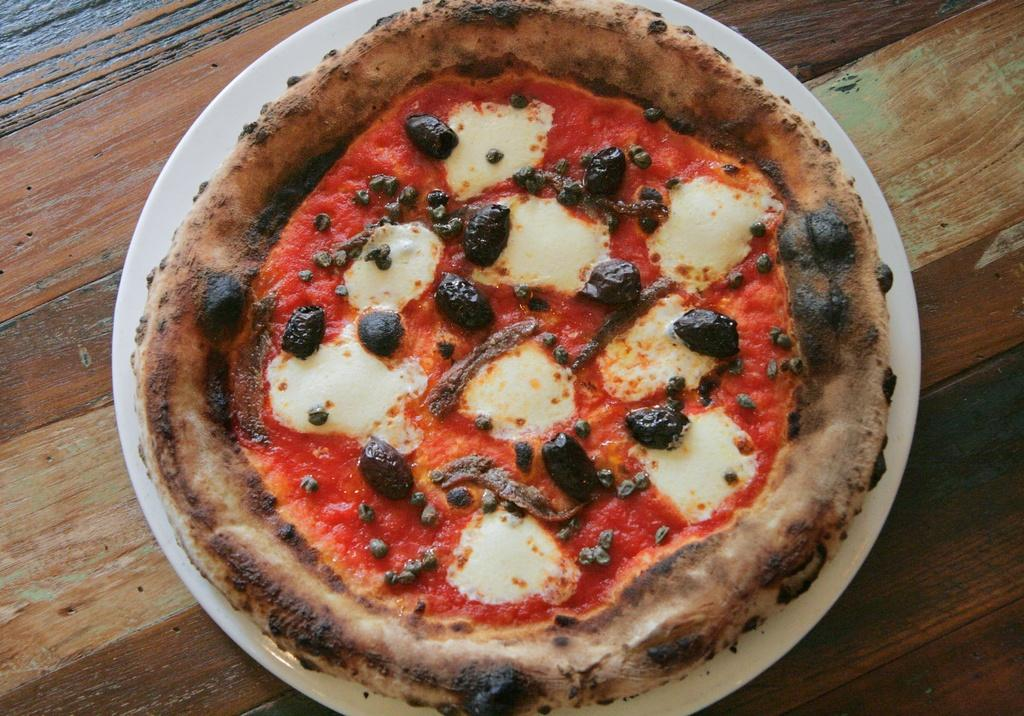What type of table is in the image? There is a wooden table in the image. What is on the table in the image? There is a pizza on a plate on the table. How many yaks are visible in the image? There are no yaks present in the image. What adjustment can be made to the fifth item in the image? There are only two items mentioned in the facts (the wooden table and the pizza on a plate), so there is no fifth item to make an adjustment to. 